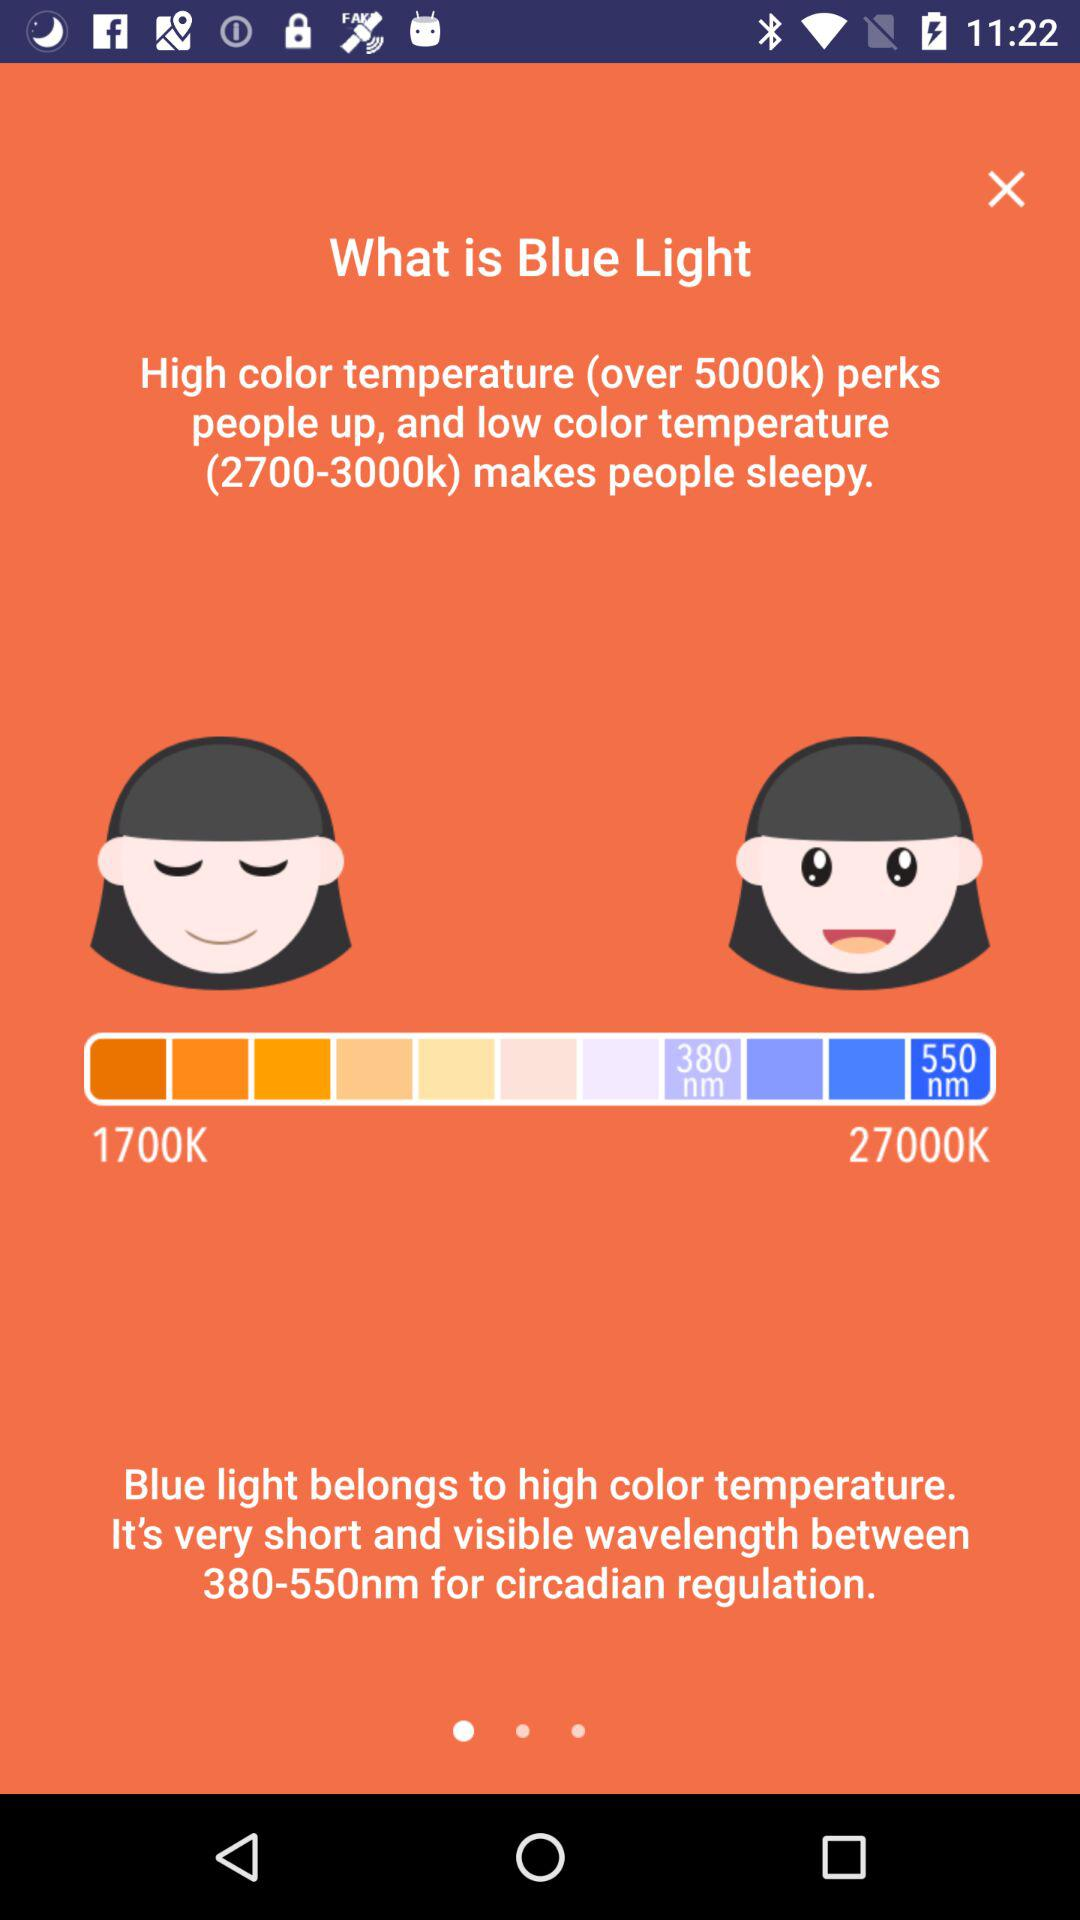Which color makes people sleepy?
When the provided information is insufficient, respond with <no answer>. <no answer> 